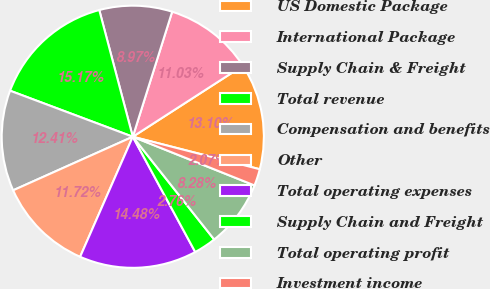Convert chart. <chart><loc_0><loc_0><loc_500><loc_500><pie_chart><fcel>US Domestic Package<fcel>International Package<fcel>Supply Chain & Freight<fcel>Total revenue<fcel>Compensation and benefits<fcel>Other<fcel>Total operating expenses<fcel>Supply Chain and Freight<fcel>Total operating profit<fcel>Investment income<nl><fcel>13.1%<fcel>11.03%<fcel>8.97%<fcel>15.17%<fcel>12.41%<fcel>11.72%<fcel>14.48%<fcel>2.76%<fcel>8.28%<fcel>2.07%<nl></chart> 